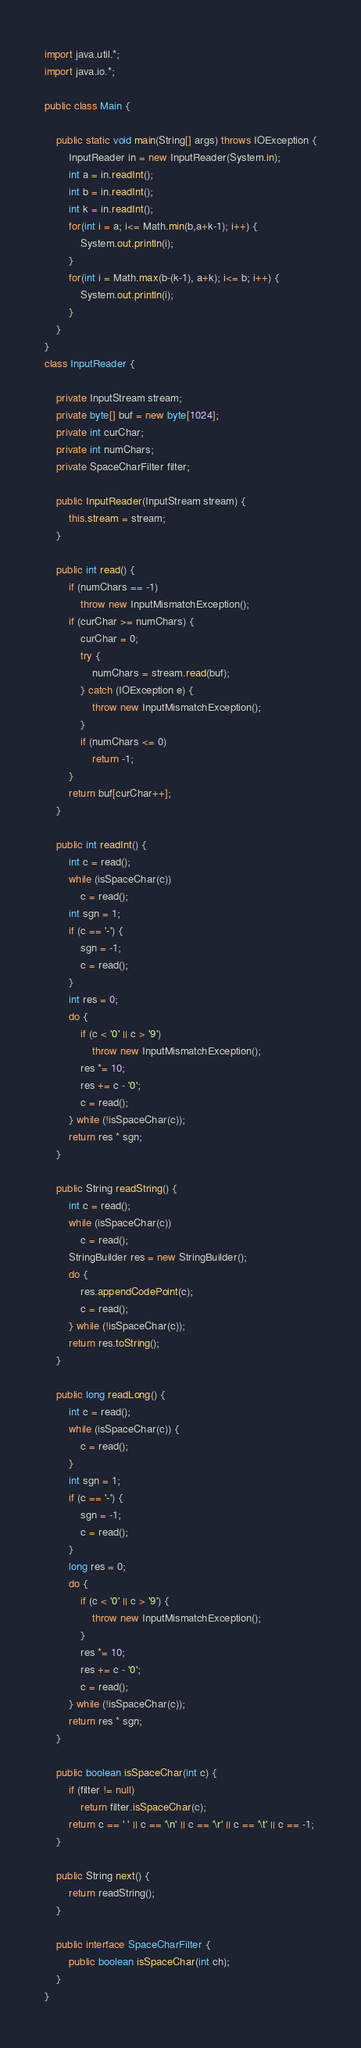<code> <loc_0><loc_0><loc_500><loc_500><_Java_>import java.util.*;
import java.io.*;

public class Main {
   
	public static void main(String[] args) throws IOException {
		InputReader in = new InputReader(System.in);
		int a = in.readInt();
		int b = in.readInt();
		int k = in.readInt();
		for(int i = a; i<= Math.min(b,a+k-1); i++) {
			System.out.println(i);
		}
		for(int i = Math.max(b-(k-1), a+k); i<= b; i++) {
			System.out.println(i);
		}
	}
}
class InputReader {

	private InputStream stream;
	private byte[] buf = new byte[1024];
	private int curChar;
	private int numChars;
	private SpaceCharFilter filter;

	public InputReader(InputStream stream) {
		this.stream = stream;
	}

	public int read() {
		if (numChars == -1)
			throw new InputMismatchException();
		if (curChar >= numChars) {
			curChar = 0;
			try {
				numChars = stream.read(buf);
			} catch (IOException e) {
				throw new InputMismatchException();
			}
			if (numChars <= 0)
				return -1;
		}
		return buf[curChar++];
	}

	public int readInt() {
		int c = read();
		while (isSpaceChar(c))
			c = read();
		int sgn = 1;
		if (c == '-') {
			sgn = -1;
			c = read();
		}
		int res = 0;
		do {
			if (c < '0' || c > '9')
				throw new InputMismatchException();
			res *= 10;
			res += c - '0';
			c = read();
		} while (!isSpaceChar(c));
		return res * sgn;
	}

	public String readString() {
		int c = read();
		while (isSpaceChar(c))
			c = read();
		StringBuilder res = new StringBuilder();
		do {
			res.appendCodePoint(c);
			c = read();
		} while (!isSpaceChar(c));
		return res.toString();
	}

	public long readLong() {
		int c = read();
		while (isSpaceChar(c)) {
			c = read();
		}
		int sgn = 1;
		if (c == '-') {
			sgn = -1;
			c = read();
		}
		long res = 0;
		do {
			if (c < '0' || c > '9') {
				throw new InputMismatchException();
			}
			res *= 10;
			res += c - '0';
			c = read();
		} while (!isSpaceChar(c));
		return res * sgn;
	}
	
	public boolean isSpaceChar(int c) {
		if (filter != null)
			return filter.isSpaceChar(c);
		return c == ' ' || c == '\n' || c == '\r' || c == '\t' || c == -1;
	}

	public String next() {
		return readString();
	}

	public interface SpaceCharFilter {
		public boolean isSpaceChar(int ch);
	}
}
</code> 